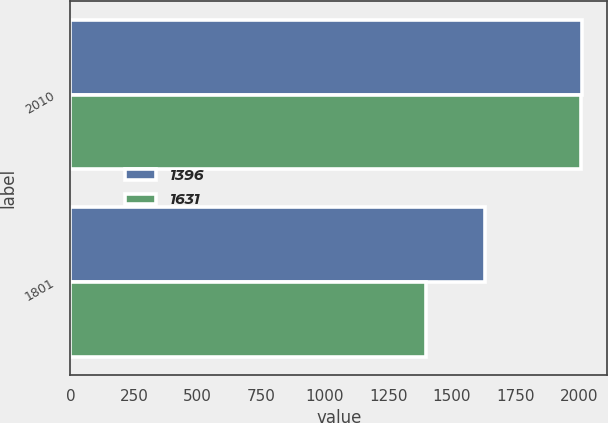Convert chart. <chart><loc_0><loc_0><loc_500><loc_500><stacked_bar_chart><ecel><fcel>2010<fcel>1801<nl><fcel>1396<fcel>2009<fcel>1631<nl><fcel>1631<fcel>2008<fcel>1396<nl></chart> 